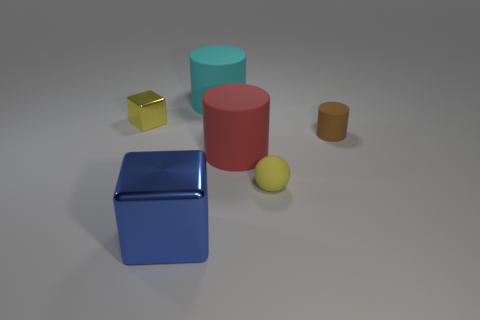Subtract all large rubber cylinders. How many cylinders are left? 1 Add 3 tiny yellow cubes. How many objects exist? 9 Subtract all blue blocks. How many blocks are left? 1 Subtract 1 cubes. How many cubes are left? 1 Subtract all yellow cubes. Subtract all brown cylinders. How many cubes are left? 1 Subtract all blue cylinders. How many yellow blocks are left? 1 Subtract all yellow metallic things. Subtract all big red rubber cylinders. How many objects are left? 4 Add 1 big cyan things. How many big cyan things are left? 2 Add 2 blue shiny cubes. How many blue shiny cubes exist? 3 Subtract 0 green cylinders. How many objects are left? 6 